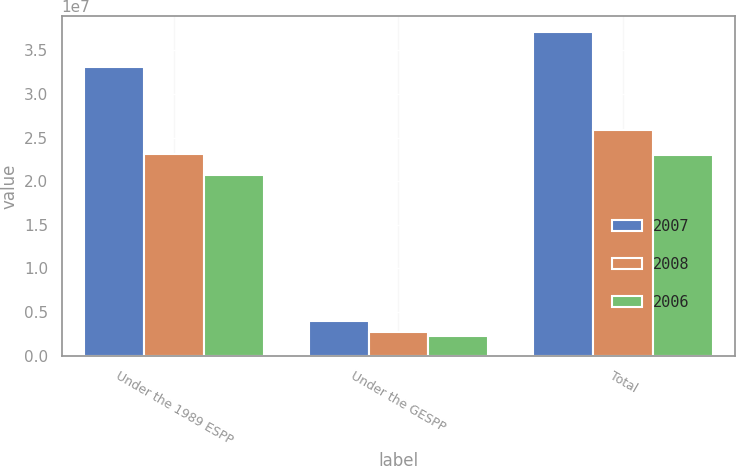Convert chart to OTSL. <chart><loc_0><loc_0><loc_500><loc_500><stacked_bar_chart><ecel><fcel>Under the 1989 ESPP<fcel>Under the GESPP<fcel>Total<nl><fcel>2007<fcel>3.30924e+07<fcel>3.9457e+06<fcel>3.70381e+07<nl><fcel>2008<fcel>2.30789e+07<fcel>2.72752e+06<fcel>2.58064e+07<nl><fcel>2006<fcel>2.06859e+07<fcel>2.30714e+06<fcel>2.2993e+07<nl></chart> 